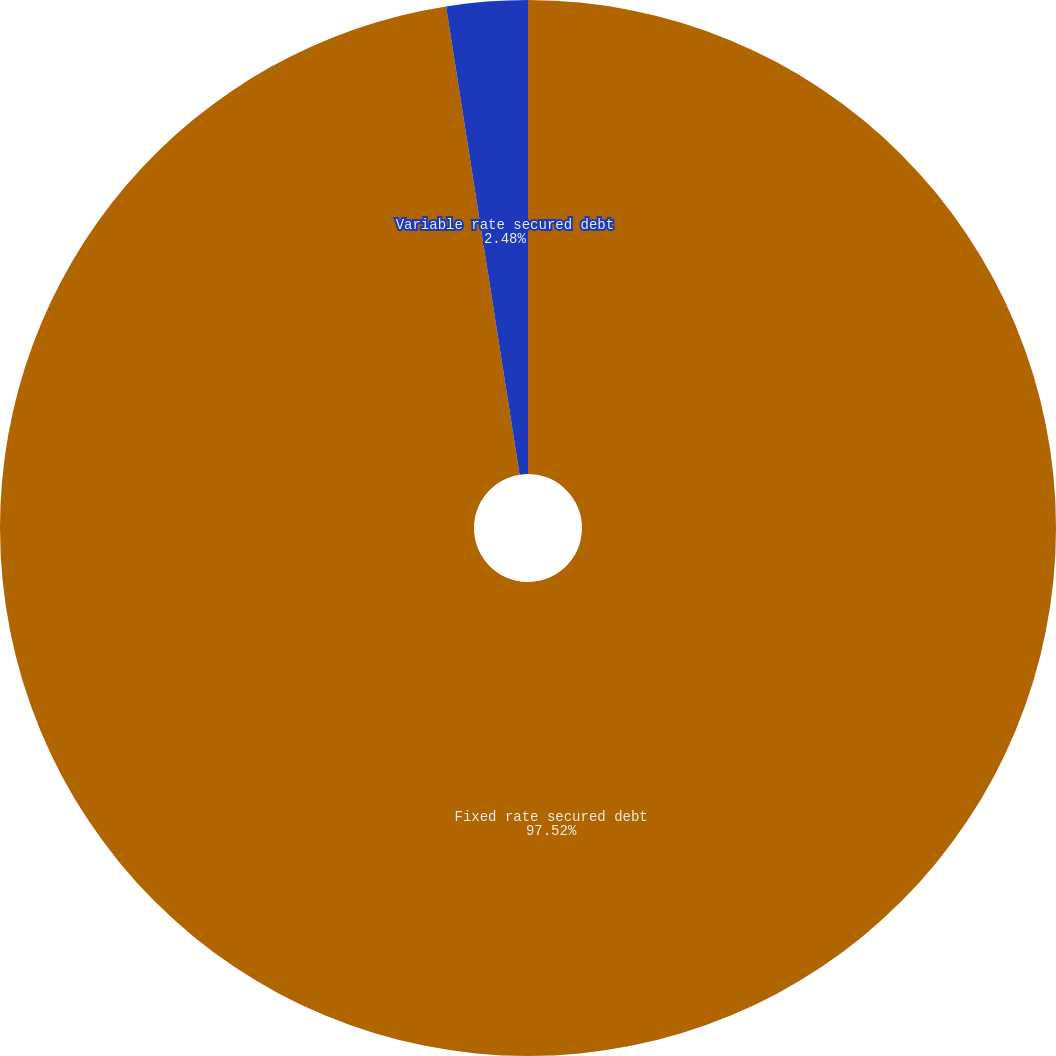<chart> <loc_0><loc_0><loc_500><loc_500><pie_chart><fcel>Fixed rate secured debt<fcel>Variable rate secured debt<nl><fcel>97.52%<fcel>2.48%<nl></chart> 